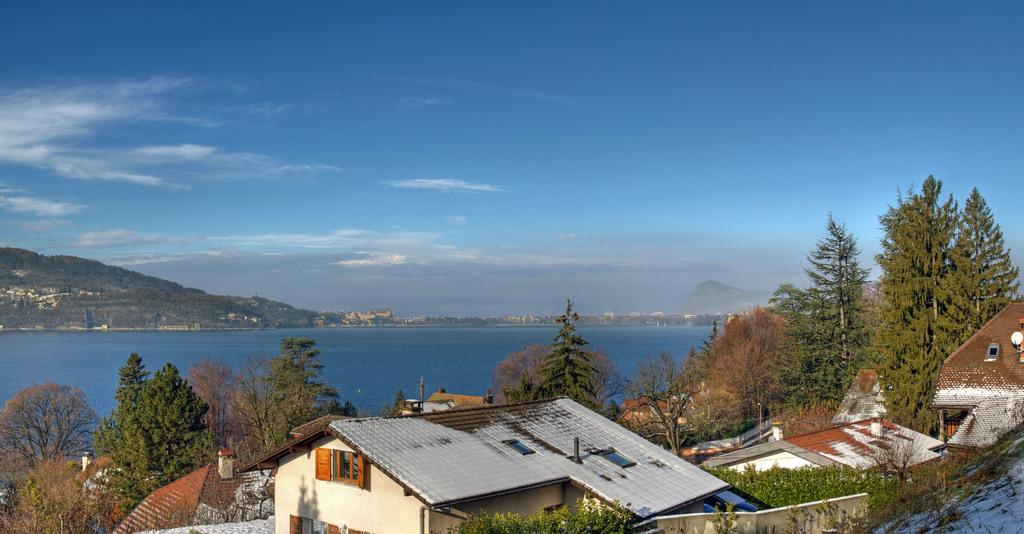What types of structures and vegetation are located at the bottom of the image? There are houses and trees at the bottom of the image. What is the main feature in the middle of the image? There is water in the middle of the image. What can be seen at the top of the image? The sky is visible at the top of the image. How many clocks are hanging from the trees in the image? There are no clocks hanging from the trees in the image. Can you describe the squirrel's behavior near the water in the image? There is no squirrel present in the image. 